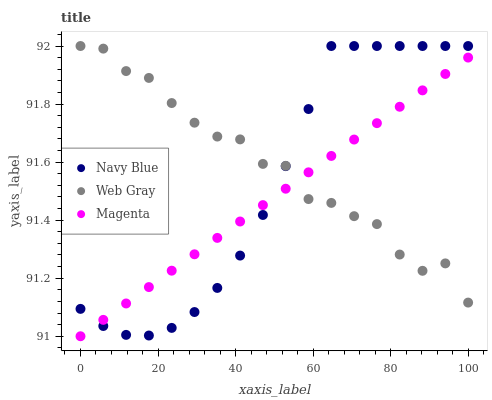Does Magenta have the minimum area under the curve?
Answer yes or no. Yes. Does Web Gray have the maximum area under the curve?
Answer yes or no. Yes. Does Web Gray have the minimum area under the curve?
Answer yes or no. No. Does Magenta have the maximum area under the curve?
Answer yes or no. No. Is Magenta the smoothest?
Answer yes or no. Yes. Is Web Gray the roughest?
Answer yes or no. Yes. Is Web Gray the smoothest?
Answer yes or no. No. Is Magenta the roughest?
Answer yes or no. No. Does Magenta have the lowest value?
Answer yes or no. Yes. Does Web Gray have the lowest value?
Answer yes or no. No. Does Web Gray have the highest value?
Answer yes or no. Yes. Does Magenta have the highest value?
Answer yes or no. No. Does Magenta intersect Navy Blue?
Answer yes or no. Yes. Is Magenta less than Navy Blue?
Answer yes or no. No. Is Magenta greater than Navy Blue?
Answer yes or no. No. 